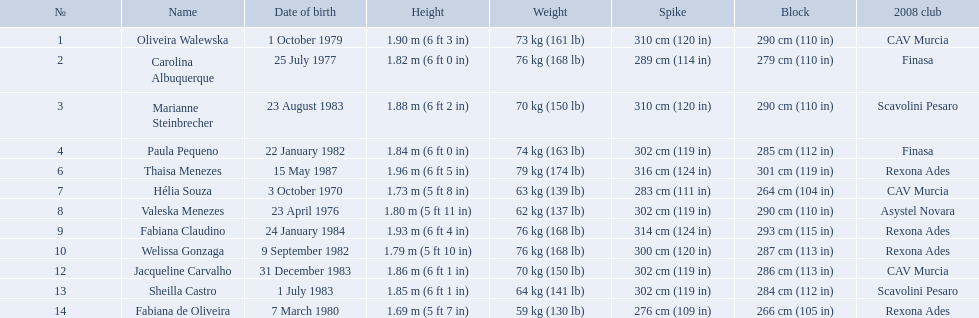How much does fabiana de oliveira weigh? 76 kg (168 lb). How much does helia souza weigh? 63 kg (139 lb). How much does sheilla castro weigh? 64 kg (141 lb). Whose weight did the original question asker incorrectly believe to be the heaviest (they are the second heaviest)? Sheilla Castro. What are the names of all the contestants? Oliveira Walewska, Carolina Albuquerque, Marianne Steinbrecher, Paula Pequeno, Thaisa Menezes, Hélia Souza, Valeska Menezes, Fabiana Claudino, Welissa Gonzaga, Jacqueline Carvalho, Sheilla Castro, Fabiana de Oliveira. What are the weight ranges of the contestants? 73 kg (161 lb), 76 kg (168 lb), 70 kg (150 lb), 74 kg (163 lb), 79 kg (174 lb), 63 kg (139 lb), 62 kg (137 lb), 76 kg (168 lb), 76 kg (168 lb), 70 kg (150 lb), 64 kg (141 lb), 59 kg (130 lb). Give me the full table as a dictionary. {'header': ['№', 'Name', 'Date of birth', 'Height', 'Weight', 'Spike', 'Block', '2008 club'], 'rows': [['1', 'Oliveira Walewska', '1 October 1979', '1.90\xa0m (6\xa0ft 3\xa0in)', '73\xa0kg (161\xa0lb)', '310\xa0cm (120\xa0in)', '290\xa0cm (110\xa0in)', 'CAV Murcia'], ['2', 'Carolina Albuquerque', '25 July 1977', '1.82\xa0m (6\xa0ft 0\xa0in)', '76\xa0kg (168\xa0lb)', '289\xa0cm (114\xa0in)', '279\xa0cm (110\xa0in)', 'Finasa'], ['3', 'Marianne Steinbrecher', '23 August 1983', '1.88\xa0m (6\xa0ft 2\xa0in)', '70\xa0kg (150\xa0lb)', '310\xa0cm (120\xa0in)', '290\xa0cm (110\xa0in)', 'Scavolini Pesaro'], ['4', 'Paula Pequeno', '22 January 1982', '1.84\xa0m (6\xa0ft 0\xa0in)', '74\xa0kg (163\xa0lb)', '302\xa0cm (119\xa0in)', '285\xa0cm (112\xa0in)', 'Finasa'], ['6', 'Thaisa Menezes', '15 May 1987', '1.96\xa0m (6\xa0ft 5\xa0in)', '79\xa0kg (174\xa0lb)', '316\xa0cm (124\xa0in)', '301\xa0cm (119\xa0in)', 'Rexona Ades'], ['7', 'Hélia Souza', '3 October 1970', '1.73\xa0m (5\xa0ft 8\xa0in)', '63\xa0kg (139\xa0lb)', '283\xa0cm (111\xa0in)', '264\xa0cm (104\xa0in)', 'CAV Murcia'], ['8', 'Valeska Menezes', '23 April 1976', '1.80\xa0m (5\xa0ft 11\xa0in)', '62\xa0kg (137\xa0lb)', '302\xa0cm (119\xa0in)', '290\xa0cm (110\xa0in)', 'Asystel Novara'], ['9', 'Fabiana Claudino', '24 January 1984', '1.93\xa0m (6\xa0ft 4\xa0in)', '76\xa0kg (168\xa0lb)', '314\xa0cm (124\xa0in)', '293\xa0cm (115\xa0in)', 'Rexona Ades'], ['10', 'Welissa Gonzaga', '9 September 1982', '1.79\xa0m (5\xa0ft 10\xa0in)', '76\xa0kg (168\xa0lb)', '300\xa0cm (120\xa0in)', '287\xa0cm (113\xa0in)', 'Rexona Ades'], ['12', 'Jacqueline Carvalho', '31 December 1983', '1.86\xa0m (6\xa0ft 1\xa0in)', '70\xa0kg (150\xa0lb)', '302\xa0cm (119\xa0in)', '286\xa0cm (113\xa0in)', 'CAV Murcia'], ['13', 'Sheilla Castro', '1 July 1983', '1.85\xa0m (6\xa0ft 1\xa0in)', '64\xa0kg (141\xa0lb)', '302\xa0cm (119\xa0in)', '284\xa0cm (112\xa0in)', 'Scavolini Pesaro'], ['14', 'Fabiana de Oliveira', '7 March 1980', '1.69\xa0m (5\xa0ft 7\xa0in)', '59\xa0kg (130\xa0lb)', '276\xa0cm (109\xa0in)', '266\xa0cm (105\xa0in)', 'Rexona Ades']]} Which player is heaviest. sheilla castro, fabiana de oliveira, or helia souza? Sheilla Castro. Who are the players for brazil at the 2008 summer olympics? Oliveira Walewska, Carolina Albuquerque, Marianne Steinbrecher, Paula Pequeno, Thaisa Menezes, Hélia Souza, Valeska Menezes, Fabiana Claudino, Welissa Gonzaga, Jacqueline Carvalho, Sheilla Castro, Fabiana de Oliveira. What are their heights? 1.90 m (6 ft 3 in), 1.82 m (6 ft 0 in), 1.88 m (6 ft 2 in), 1.84 m (6 ft 0 in), 1.96 m (6 ft 5 in), 1.73 m (5 ft 8 in), 1.80 m (5 ft 11 in), 1.93 m (6 ft 4 in), 1.79 m (5 ft 10 in), 1.86 m (6 ft 1 in), 1.85 m (6 ft 1 in), 1.69 m (5 ft 7 in). What is the shortest height? 1.69 m (5 ft 7 in). Which player is that? Fabiana de Oliveira. Who are the athletes representing brazil in the 2008 summer olympics? Oliveira Walewska, Carolina Albuquerque, Marianne Steinbrecher, Paula Pequeno, Thaisa Menezes, Hélia Souza, Valeska Menezes, Fabiana Claudino, Welissa Gonzaga, Jacqueline Carvalho, Sheilla Castro, Fabiana de Oliveira. What are their statures? 1.90 m (6 ft 3 in), 1.82 m (6 ft 0 in), 1.88 m (6 ft 2 in), 1.84 m (6 ft 0 in), 1.96 m (6 ft 5 in), 1.73 m (5 ft 8 in), 1.80 m (5 ft 11 in), 1.93 m (6 ft 4 in), 1.79 m (5 ft 10 in), 1.86 m (6 ft 1 in), 1.85 m (6 ft 1 in), 1.69 m (5 ft 7 in). What is the smallest stature? 1.69 m (5 ft 7 in). Which athlete is that? Fabiana de Oliveira. What are the monikers of all the participants? Oliveira Walewska, Carolina Albuquerque, Marianne Steinbrecher, Paula Pequeno, Thaisa Menezes, Hélia Souza, Valeska Menezes, Fabiana Claudino, Welissa Gonzaga, Jacqueline Carvalho, Sheilla Castro, Fabiana de Oliveira. What are the weight categories of the participants? 73 kg (161 lb), 76 kg (168 lb), 70 kg (150 lb), 74 kg (163 lb), 79 kg (174 lb), 63 kg (139 lb), 62 kg (137 lb), 76 kg (168 lb), 76 kg (168 lb), 70 kg (150 lb), 64 kg (141 lb), 59 kg (130 lb). Which athlete is heaviest - sheilla castro, fabiana de oliveira, or helia souza? Sheilla Castro. What are the statures of the players? 1.90 m (6 ft 3 in), 1.82 m (6 ft 0 in), 1.88 m (6 ft 2 in), 1.84 m (6 ft 0 in), 1.96 m (6 ft 5 in), 1.73 m (5 ft 8 in), 1.80 m (5 ft 11 in), 1.93 m (6 ft 4 in), 1.79 m (5 ft 10 in), 1.86 m (6 ft 1 in), 1.85 m (6 ft 1 in), 1.69 m (5 ft 7 in). Which of these statures is the least? 1.69 m (5 ft 7 in). Which player is 5'7 tall? Fabiana de Oliveira. What are the vertical measurements of the players? 1.90 m (6 ft 3 in), 1.82 m (6 ft 0 in), 1.88 m (6 ft 2 in), 1.84 m (6 ft 0 in), 1.96 m (6 ft 5 in), 1.73 m (5 ft 8 in), 1.80 m (5 ft 11 in), 1.93 m (6 ft 4 in), 1.79 m (5 ft 10 in), 1.86 m (6 ft 1 in), 1.85 m (6 ft 1 in), 1.69 m (5 ft 7 in). Which of these measurements is the lowest? 1.69 m (5 ft 7 in). Which player is 5'7 tall? Fabiana de Oliveira. What are the complete names? Oliveira Walewska, Carolina Albuquerque, Marianne Steinbrecher, Paula Pequeno, Thaisa Menezes, Hélia Souza, Valeska Menezes, Fabiana Claudino, Welissa Gonzaga, Jacqueline Carvalho, Sheilla Castro, Fabiana de Oliveira. What do they weigh? 73 kg (161 lb), 76 kg (168 lb), 70 kg (150 lb), 74 kg (163 lb), 79 kg (174 lb), 63 kg (139 lb), 62 kg (137 lb), 76 kg (168 lb), 76 kg (168 lb), 70 kg (150 lb), 64 kg (141 lb), 59 kg (130 lb). What were the weights of helia souza, fabiana de oliveira, and sheilla castro? Hélia Souza, Sheilla Castro, Fabiana de Oliveira. Who had the highest weight? Sheilla Castro. What are the complete names of each participant? Oliveira Walewska, Carolina Albuquerque, Marianne Steinbrecher, Paula Pequeno, Thaisa Menezes, Hélia Souza, Valeska Menezes, Fabiana Claudino, Welissa Gonzaga, Jacqueline Carvalho, Sheilla Castro, Fabiana de Oliveira. What are the weight categories of the competitors? 73 kg (161 lb), 76 kg (168 lb), 70 kg (150 lb), 74 kg (163 lb), 79 kg (174 lb), 63 kg (139 lb), 62 kg (137 lb), 76 kg (168 lb), 76 kg (168 lb), 70 kg (150 lb), 64 kg (141 lb), 59 kg (130 lb). Out of sheilla castro, fabiana de oliveira, and helia souza, who has the highest weight? Sheilla Castro. 